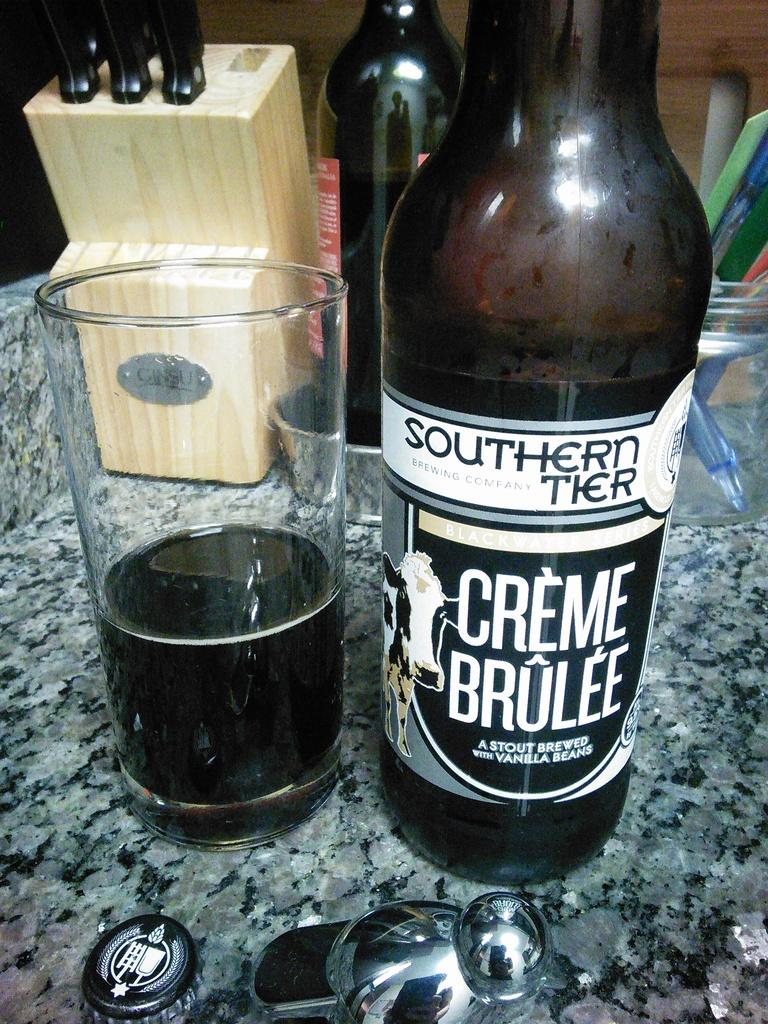<image>
Give a short and clear explanation of the subsequent image. Some of a bottle of Southern Tier Crème Brûlée has been poured into a glass next to it. 